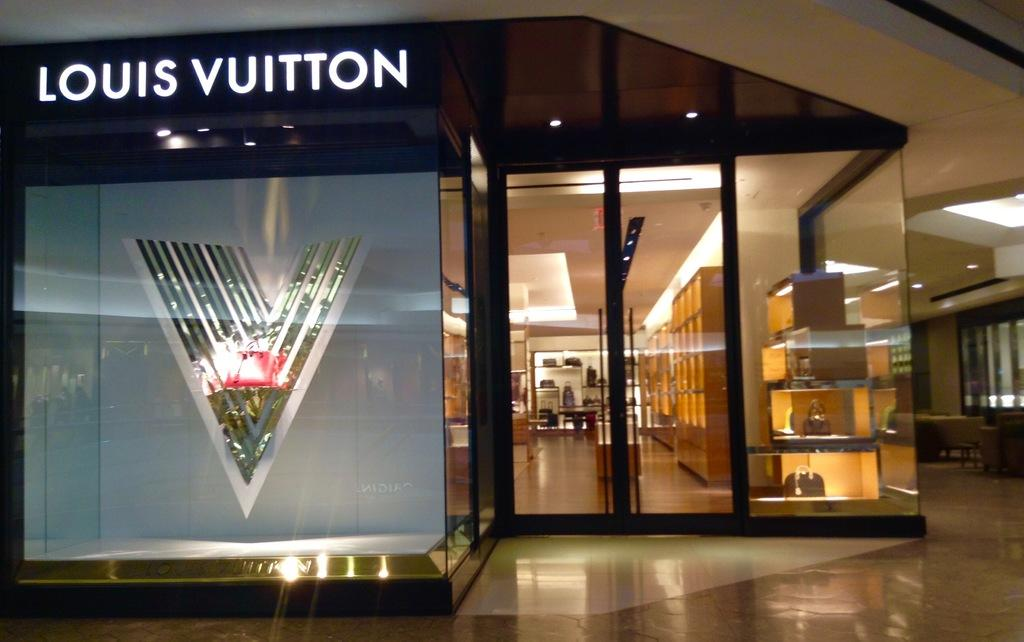<image>
Present a compact description of the photo's key features. Louis Vuitton's store beamed with light and tempted with glimpses of the wares inside. 